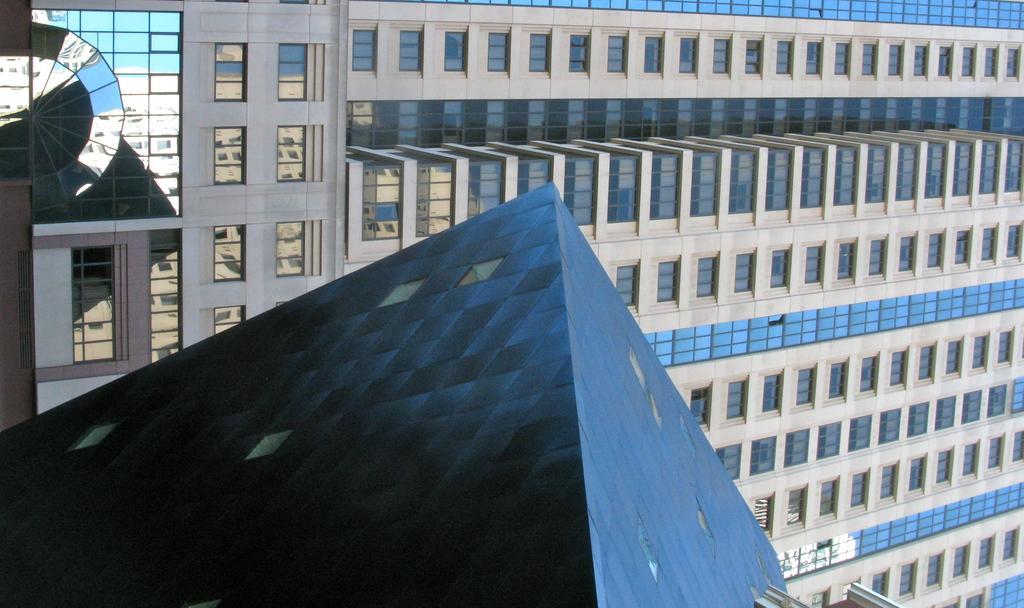Describe this image in one or two sentences. In this image I can see a building, roof and glass windows. 